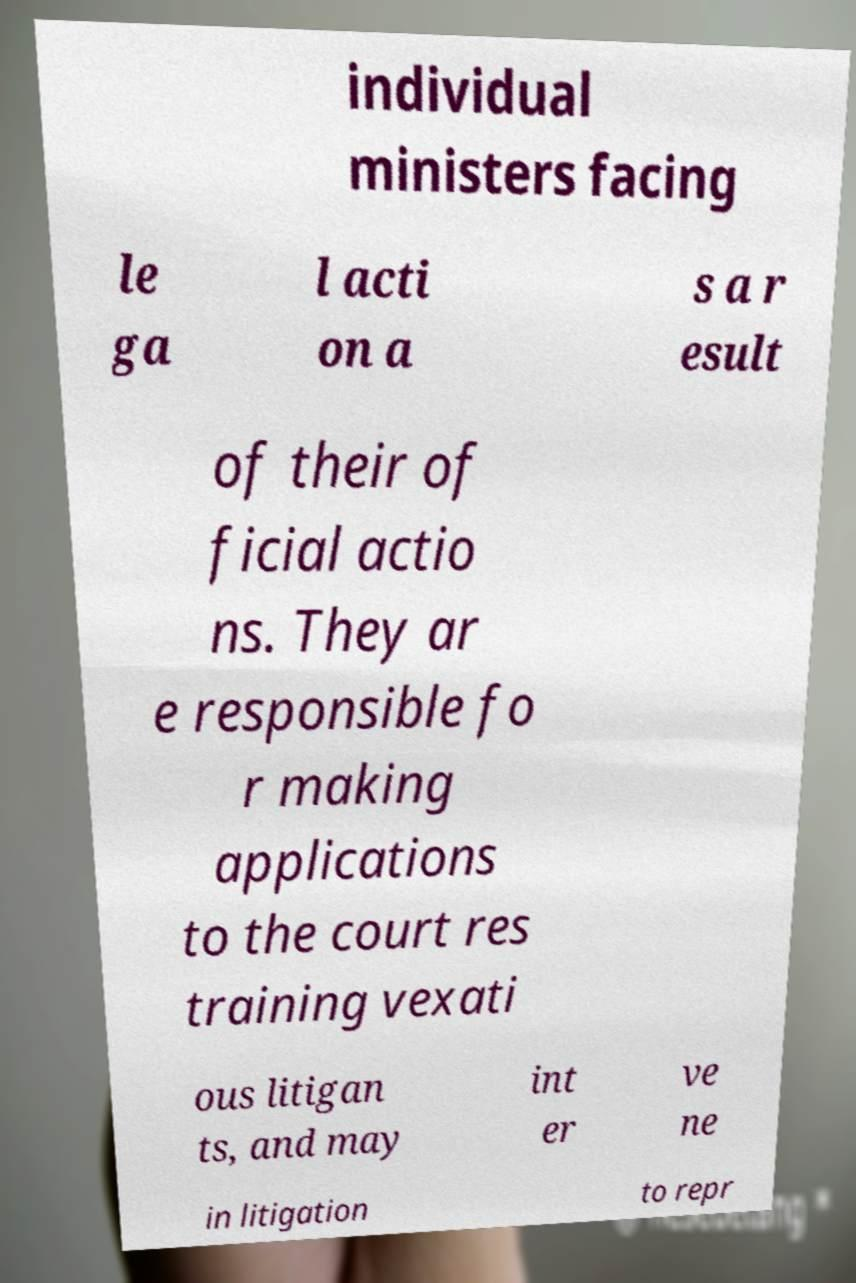Could you extract and type out the text from this image? individual ministers facing le ga l acti on a s a r esult of their of ficial actio ns. They ar e responsible fo r making applications to the court res training vexati ous litigan ts, and may int er ve ne in litigation to repr 